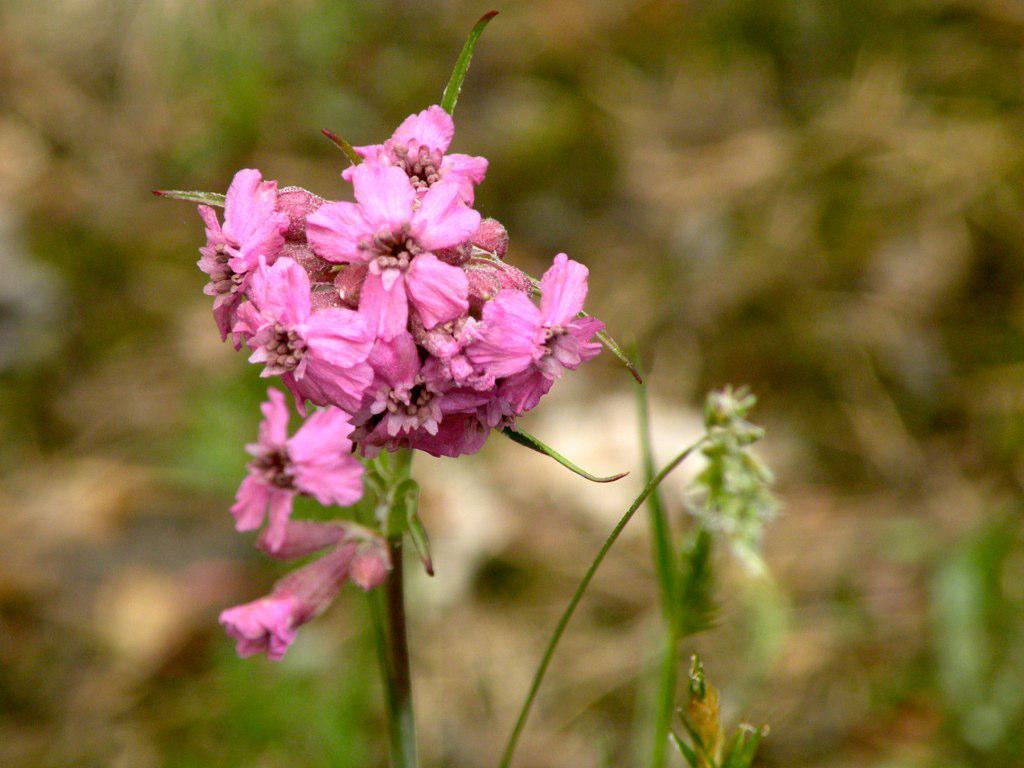How would you summarize this image in a sentence or two? In this image, we can see some flowers on blue background. 